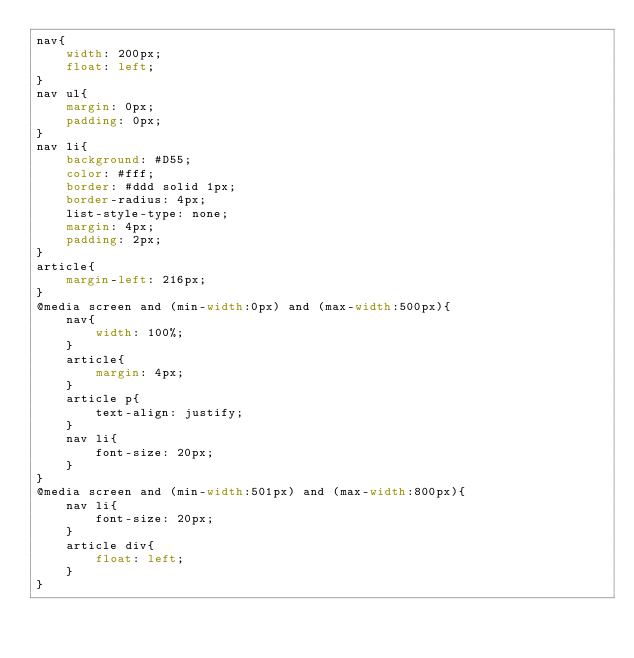Convert code to text. <code><loc_0><loc_0><loc_500><loc_500><_CSS_>nav{
    width: 200px;
    float: left;
}
nav ul{
    margin: 0px;
    padding: 0px;
}
nav li{
    background: #D55;
    color: #fff;
    border: #ddd solid 1px;
    border-radius: 4px;
    list-style-type: none;
    margin: 4px;
    padding: 2px;
}
article{
    margin-left: 216px;
}
@media screen and (min-width:0px) and (max-width:500px){
    nav{
        width: 100%;
    }
    article{
        margin: 4px;
    }
    article p{
        text-align: justify;
    }
    nav li{
        font-size: 20px;
    }
}
@media screen and (min-width:501px) and (max-width:800px){
    nav li{
        font-size: 20px;
    }
    article div{
        float: left;
    }
}</code> 